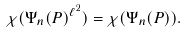Convert formula to latex. <formula><loc_0><loc_0><loc_500><loc_500>\chi ( \Psi _ { n } ( P ) ^ { \ell ^ { 2 } } ) = \chi ( \Psi _ { n } ( P ) ) .</formula> 